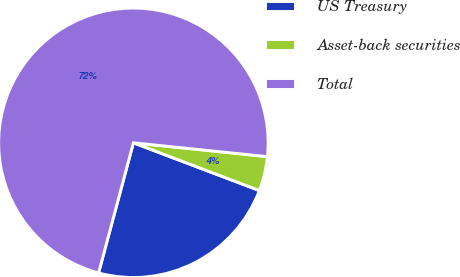<chart> <loc_0><loc_0><loc_500><loc_500><pie_chart><fcel>US Treasury<fcel>Asset-back securities<fcel>Total<nl><fcel>23.39%<fcel>4.13%<fcel>72.48%<nl></chart> 